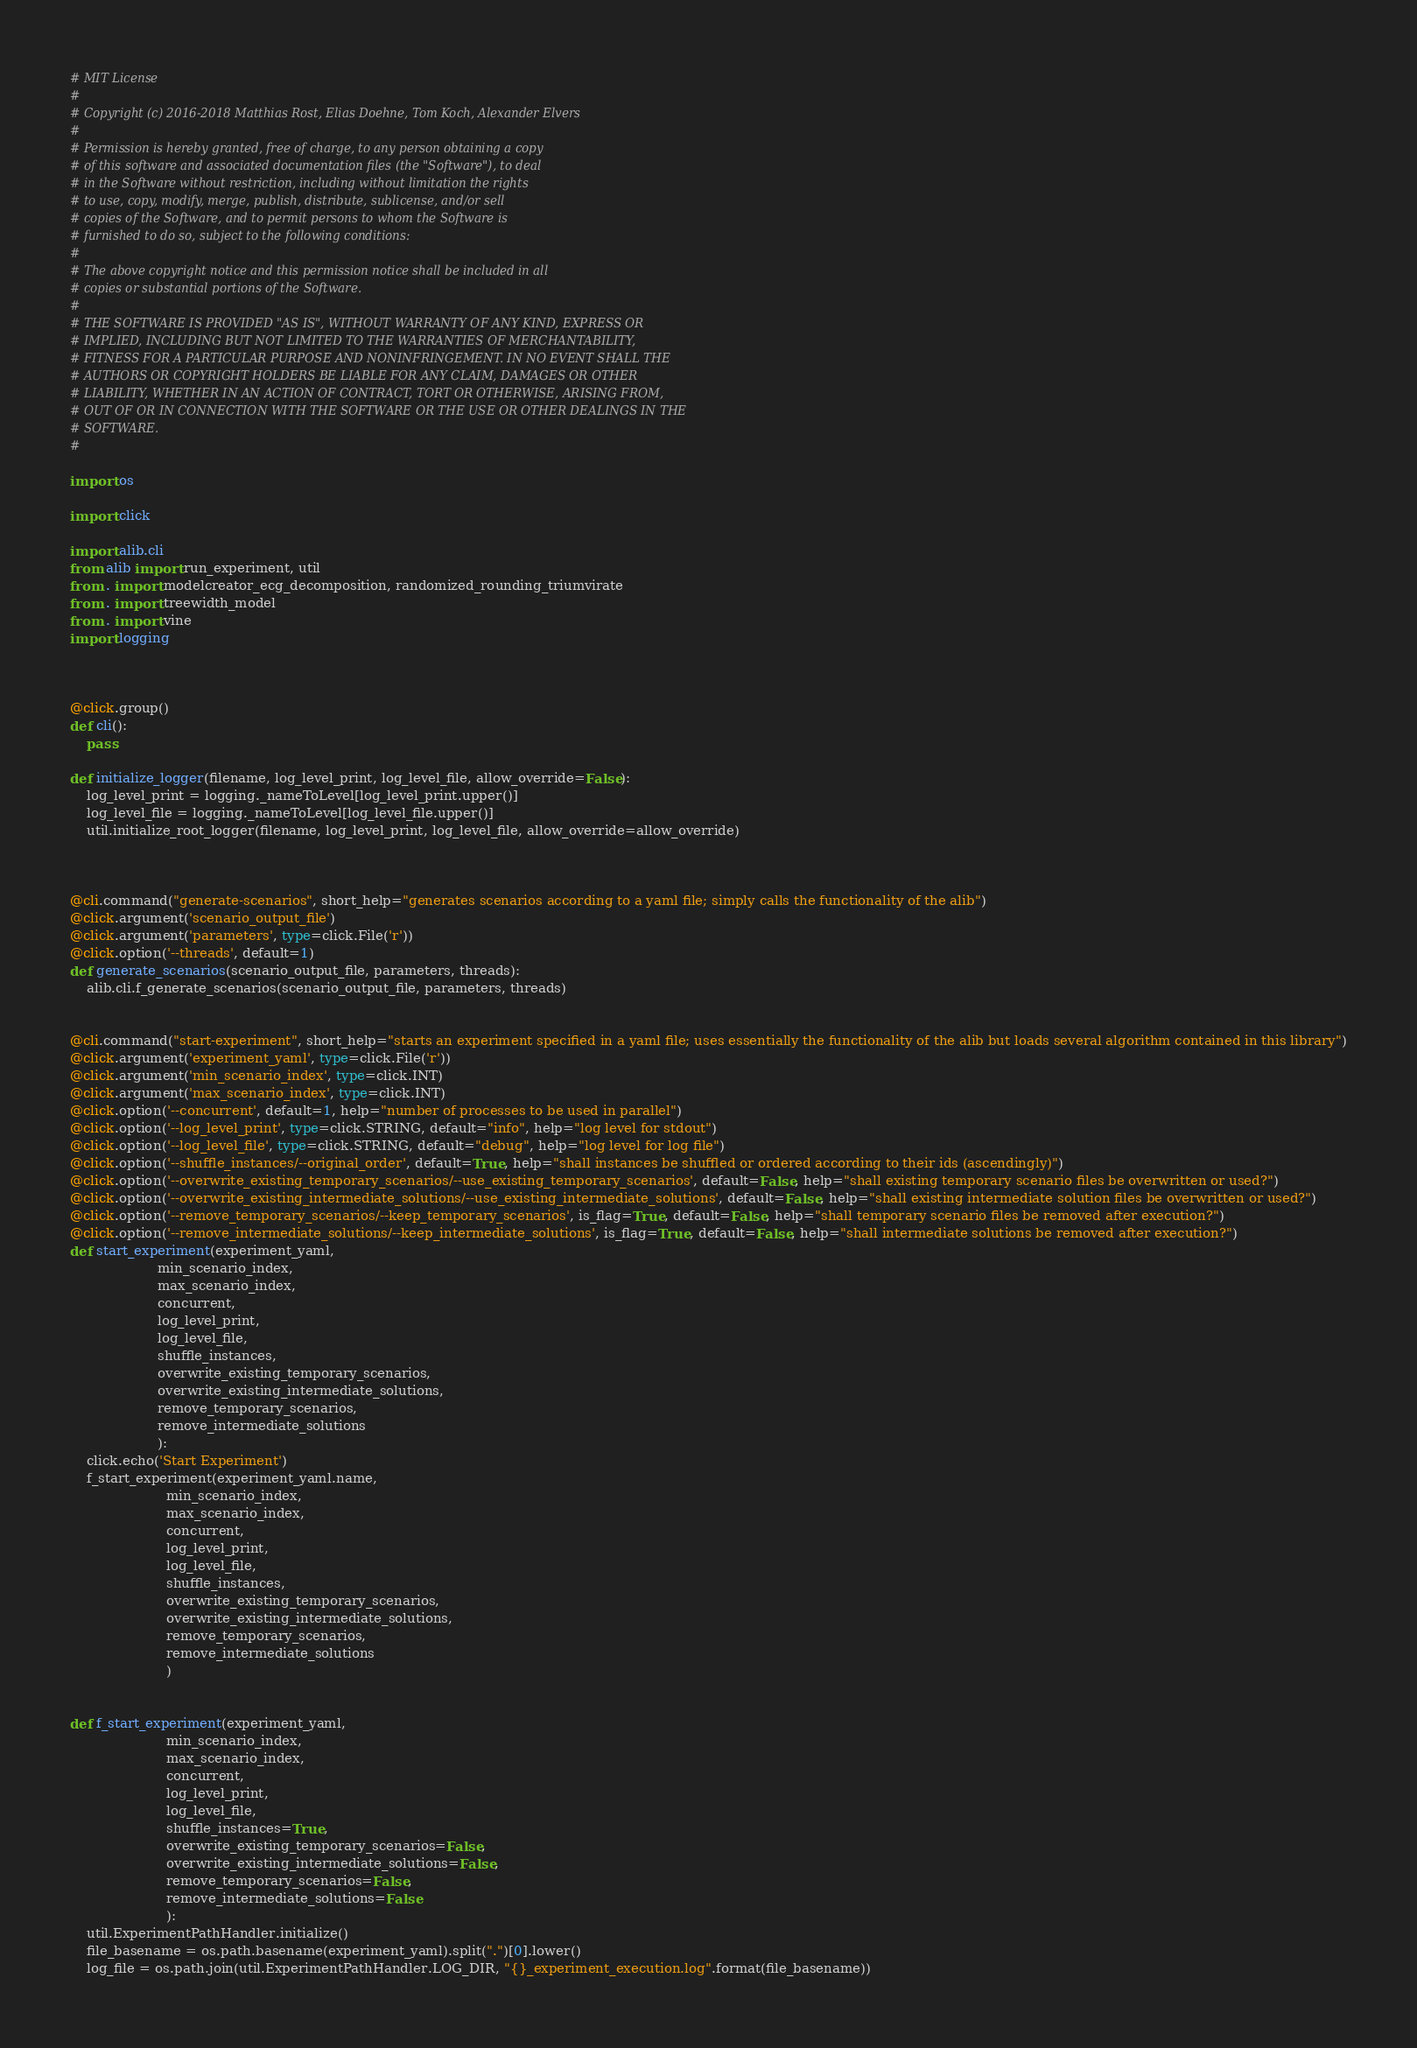Convert code to text. <code><loc_0><loc_0><loc_500><loc_500><_Python_># MIT License
#
# Copyright (c) 2016-2018 Matthias Rost, Elias Doehne, Tom Koch, Alexander Elvers
#
# Permission is hereby granted, free of charge, to any person obtaining a copy
# of this software and associated documentation files (the "Software"), to deal
# in the Software without restriction, including without limitation the rights
# to use, copy, modify, merge, publish, distribute, sublicense, and/or sell
# copies of the Software, and to permit persons to whom the Software is
# furnished to do so, subject to the following conditions:
#
# The above copyright notice and this permission notice shall be included in all
# copies or substantial portions of the Software.
#
# THE SOFTWARE IS PROVIDED "AS IS", WITHOUT WARRANTY OF ANY KIND, EXPRESS OR
# IMPLIED, INCLUDING BUT NOT LIMITED TO THE WARRANTIES OF MERCHANTABILITY,
# FITNESS FOR A PARTICULAR PURPOSE AND NONINFRINGEMENT. IN NO EVENT SHALL THE
# AUTHORS OR COPYRIGHT HOLDERS BE LIABLE FOR ANY CLAIM, DAMAGES OR OTHER
# LIABILITY, WHETHER IN AN ACTION OF CONTRACT, TORT OR OTHERWISE, ARISING FROM,
# OUT OF OR IN CONNECTION WITH THE SOFTWARE OR THE USE OR OTHER DEALINGS IN THE
# SOFTWARE.
#

import os

import click

import alib.cli
from alib import run_experiment, util
from . import modelcreator_ecg_decomposition, randomized_rounding_triumvirate
from . import treewidth_model
from . import vine
import logging



@click.group()
def cli():
    pass

def initialize_logger(filename, log_level_print, log_level_file, allow_override=False):
    log_level_print = logging._nameToLevel[log_level_print.upper()]
    log_level_file = logging._nameToLevel[log_level_file.upper()]
    util.initialize_root_logger(filename, log_level_print, log_level_file, allow_override=allow_override)



@cli.command("generate-scenarios", short_help="generates scenarios according to a yaml file; simply calls the functionality of the alib")
@click.argument('scenario_output_file')
@click.argument('parameters', type=click.File('r'))
@click.option('--threads', default=1)
def generate_scenarios(scenario_output_file, parameters, threads):
    alib.cli.f_generate_scenarios(scenario_output_file, parameters, threads)


@cli.command("start-experiment", short_help="starts an experiment specified in a yaml file; uses essentially the functionality of the alib but loads several algorithm contained in this library")
@click.argument('experiment_yaml', type=click.File('r'))
@click.argument('min_scenario_index', type=click.INT)
@click.argument('max_scenario_index', type=click.INT)
@click.option('--concurrent', default=1, help="number of processes to be used in parallel")
@click.option('--log_level_print', type=click.STRING, default="info", help="log level for stdout")
@click.option('--log_level_file', type=click.STRING, default="debug", help="log level for log file")
@click.option('--shuffle_instances/--original_order', default=True, help="shall instances be shuffled or ordered according to their ids (ascendingly)")
@click.option('--overwrite_existing_temporary_scenarios/--use_existing_temporary_scenarios', default=False, help="shall existing temporary scenario files be overwritten or used?")
@click.option('--overwrite_existing_intermediate_solutions/--use_existing_intermediate_solutions', default=False, help="shall existing intermediate solution files be overwritten or used?")
@click.option('--remove_temporary_scenarios/--keep_temporary_scenarios', is_flag=True, default=False, help="shall temporary scenario files be removed after execution?")
@click.option('--remove_intermediate_solutions/--keep_intermediate_solutions', is_flag=True, default=False, help="shall intermediate solutions be removed after execution?")
def start_experiment(experiment_yaml,
                     min_scenario_index,
                     max_scenario_index,
                     concurrent,
                     log_level_print,
                     log_level_file,
                     shuffle_instances,
                     overwrite_existing_temporary_scenarios,
                     overwrite_existing_intermediate_solutions,
                     remove_temporary_scenarios,
                     remove_intermediate_solutions
                     ):
    click.echo('Start Experiment')
    f_start_experiment(experiment_yaml.name,
                       min_scenario_index,
                       max_scenario_index,
                       concurrent,
                       log_level_print,
                       log_level_file,
                       shuffle_instances,
                       overwrite_existing_temporary_scenarios,
                       overwrite_existing_intermediate_solutions,
                       remove_temporary_scenarios,
                       remove_intermediate_solutions
                       )


def f_start_experiment(experiment_yaml,
                       min_scenario_index,
                       max_scenario_index,
                       concurrent,
                       log_level_print,
                       log_level_file,
                       shuffle_instances=True,
                       overwrite_existing_temporary_scenarios=False,
                       overwrite_existing_intermediate_solutions=False,
                       remove_temporary_scenarios=False,
                       remove_intermediate_solutions=False
                       ):
    util.ExperimentPathHandler.initialize()
    file_basename = os.path.basename(experiment_yaml).split(".")[0].lower()
    log_file = os.path.join(util.ExperimentPathHandler.LOG_DIR, "{}_experiment_execution.log".format(file_basename))
</code> 